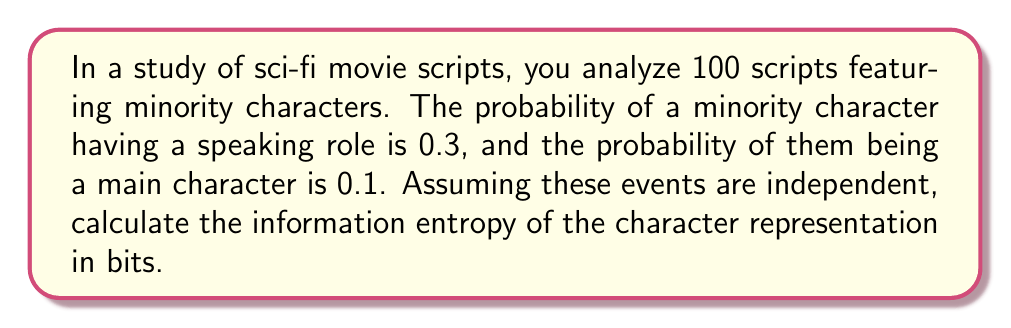Give your solution to this math problem. To calculate the information entropy, we'll use Shannon's entropy formula:

$$H = -\sum_{i=1}^{n} p_i \log_2(p_i)$$

Where $p_i$ is the probability of each possible outcome.

In this case, we have four possible outcomes:
1. Minority character has no role: $p_1 = 0.6$
2. Minority character has a speaking role but is not a main character: $p_2 = 0.3 \times 0.9 = 0.27$
3. Minority character is a main character but has no speaking role: $p_3 = 0.1 \times 0.7 = 0.07$
4. Minority character is both a main character and has a speaking role: $p_4 = 0.1 \times 0.3 = 0.03$

Now, let's calculate the entropy:

$$\begin{align}
H &= -[0.6 \log_2(0.6) + 0.27 \log_2(0.27) + 0.07 \log_2(0.07) + 0.03 \log_2(0.03)] \\
&= -[0.6 \times (-0.737) + 0.27 \times (-1.889) + 0.07 \times (-3.837) + 0.03 \times (-5.059)] \\
&= 0.442 + 0.510 + 0.269 + 0.152 \\
&= 1.373 \text{ bits}
\end{align}$$
Answer: 1.373 bits 